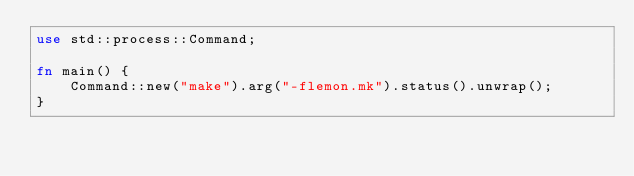<code> <loc_0><loc_0><loc_500><loc_500><_Rust_>use std::process::Command;

fn main() {
    Command::new("make").arg("-flemon.mk").status().unwrap();
}
</code> 